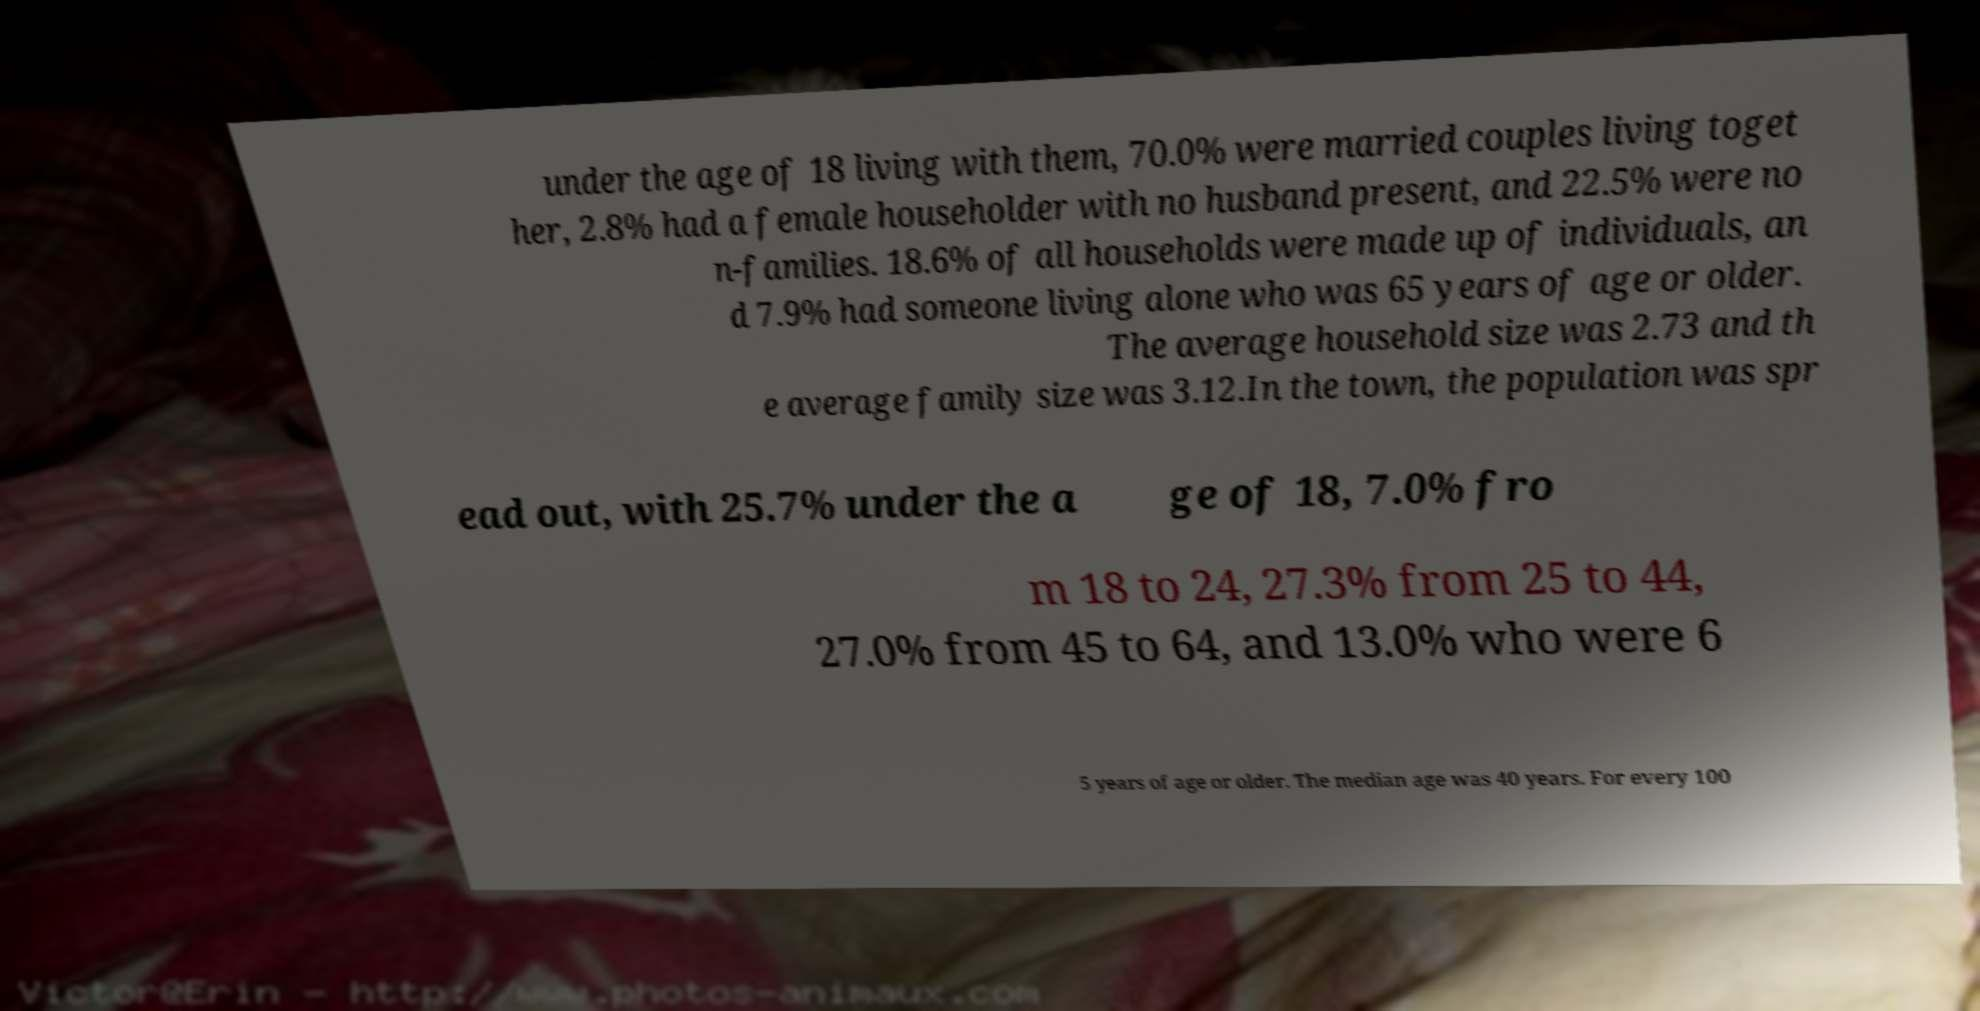Please identify and transcribe the text found in this image. under the age of 18 living with them, 70.0% were married couples living toget her, 2.8% had a female householder with no husband present, and 22.5% were no n-families. 18.6% of all households were made up of individuals, an d 7.9% had someone living alone who was 65 years of age or older. The average household size was 2.73 and th e average family size was 3.12.In the town, the population was spr ead out, with 25.7% under the a ge of 18, 7.0% fro m 18 to 24, 27.3% from 25 to 44, 27.0% from 45 to 64, and 13.0% who were 6 5 years of age or older. The median age was 40 years. For every 100 